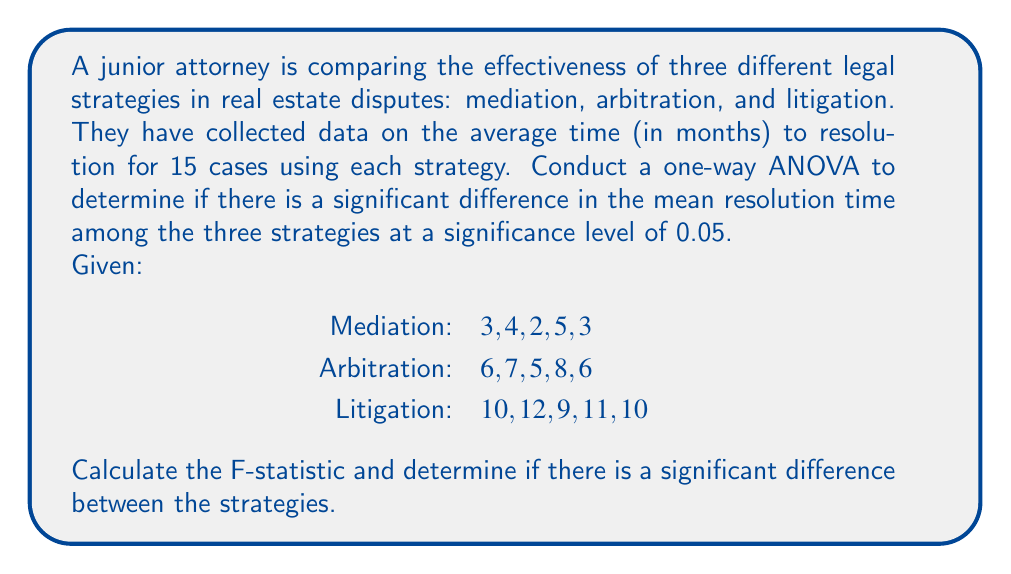Teach me how to tackle this problem. To conduct a one-way ANOVA, we'll follow these steps:

1. Calculate the sum of squares between groups (SSB), within groups (SSW), and total (SST).
2. Calculate the degrees of freedom for between groups (dfB), within groups (dfW), and total (dfT).
3. Calculate the mean squares between groups (MSB) and within groups (MSW).
4. Calculate the F-statistic.
5. Compare the F-statistic to the critical F-value.

Step 1: Calculate sums of squares

First, we need to calculate the grand mean:
$$\bar{X} = \frac{3+4+2+5+3+6+7+5+8+6+10+12+9+11+10}{15} = 6.73$$

Now, we can calculate SSB, SSW, and SST:

SSB:
$$SSB = 5[(3.4-6.73)^2 + (6.4-6.73)^2 + (10.4-6.73)^2] = 147.73$$

SSW:
$$SSW = [(3-3.4)^2 + (4-3.4)^2 + (2-3.4)^2 + (5-3.4)^2 + (3-3.4)^2] + \\
[(6-6.4)^2 + (7-6.4)^2 + (5-6.4)^2 + (8-6.4)^2 + (6-6.4)^2] + \\
[(10-10.4)^2 + (12-10.4)^2 + (9-10.4)^2 + (11-10.4)^2 + (10-10.4)^2] = 19.2$$

SST:
$$SST = SSB + SSW = 147.73 + 19.2 = 166.93$$

Step 2: Calculate degrees of freedom

dfB = number of groups - 1 = 3 - 1 = 2
dfW = total number of observations - number of groups = 15 - 3 = 12
dfT = total number of observations - 1 = 15 - 1 = 14

Step 3: Calculate mean squares

$$MSB = \frac{SSB}{dfB} = \frac{147.73}{2} = 73.865$$
$$MSW = \frac{SSW}{dfW} = \frac{19.2}{12} = 1.6$$

Step 4: Calculate F-statistic

$$F = \frac{MSB}{MSW} = \frac{73.865}{1.6} = 46.16$$

Step 5: Compare F-statistic to critical F-value

The critical F-value for α = 0.05, dfB = 2, and dfW = 12 is approximately 3.89 (obtained from an F-distribution table).

Since our calculated F-statistic (46.16) is greater than the critical F-value (3.89), we reject the null hypothesis.
Answer: F-statistic = 46.16

There is a significant difference in the mean resolution time among the three legal strategies (mediation, arbitration, and litigation) at the 0.05 significance level. 